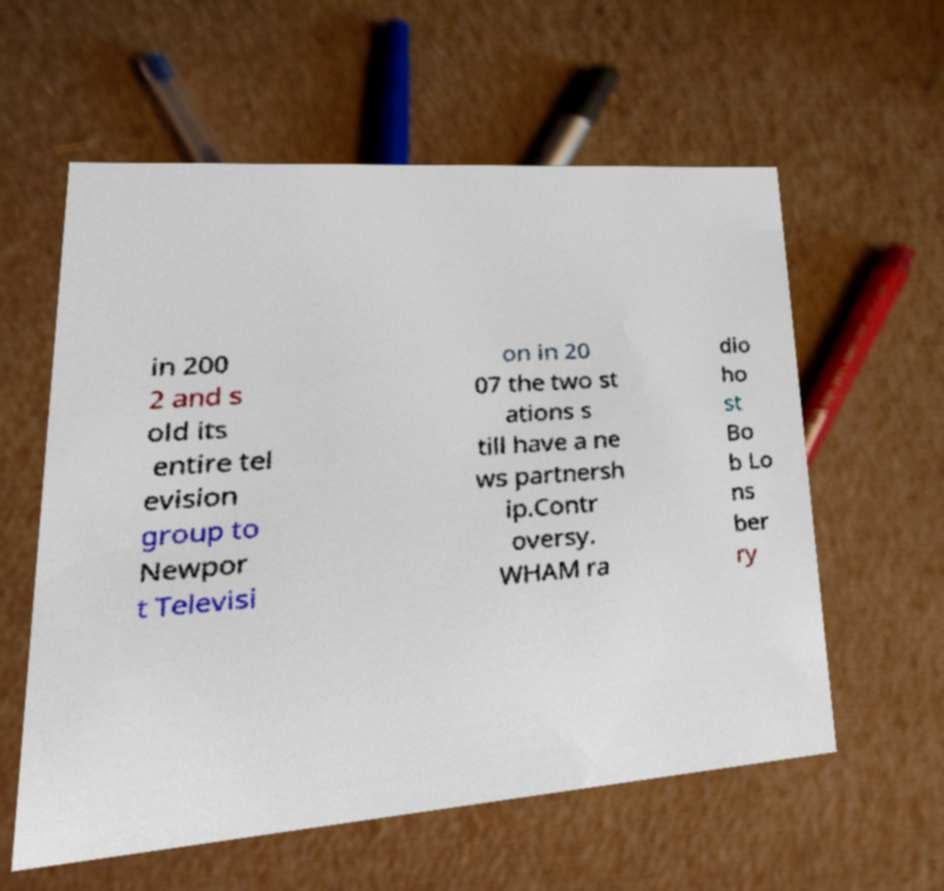Please identify and transcribe the text found in this image. in 200 2 and s old its entire tel evision group to Newpor t Televisi on in 20 07 the two st ations s till have a ne ws partnersh ip.Contr oversy. WHAM ra dio ho st Bo b Lo ns ber ry 